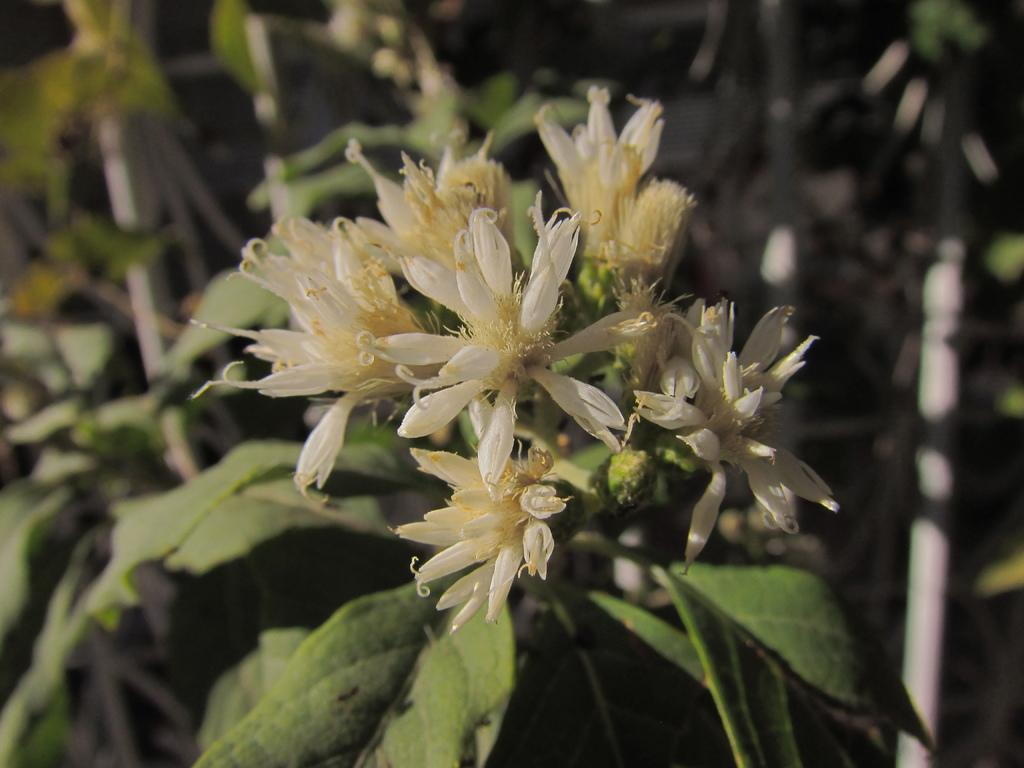What colors are the flowers in the image? The flowers in the image are white and cream colored. What other part of the plant can be seen in the image besides the flowers? Green leaves are visible in the image. What type of stocking is the parent wearing in the image? There is no parent or stocking present in the image; it only features white and cream colored flowers and green leaves. 